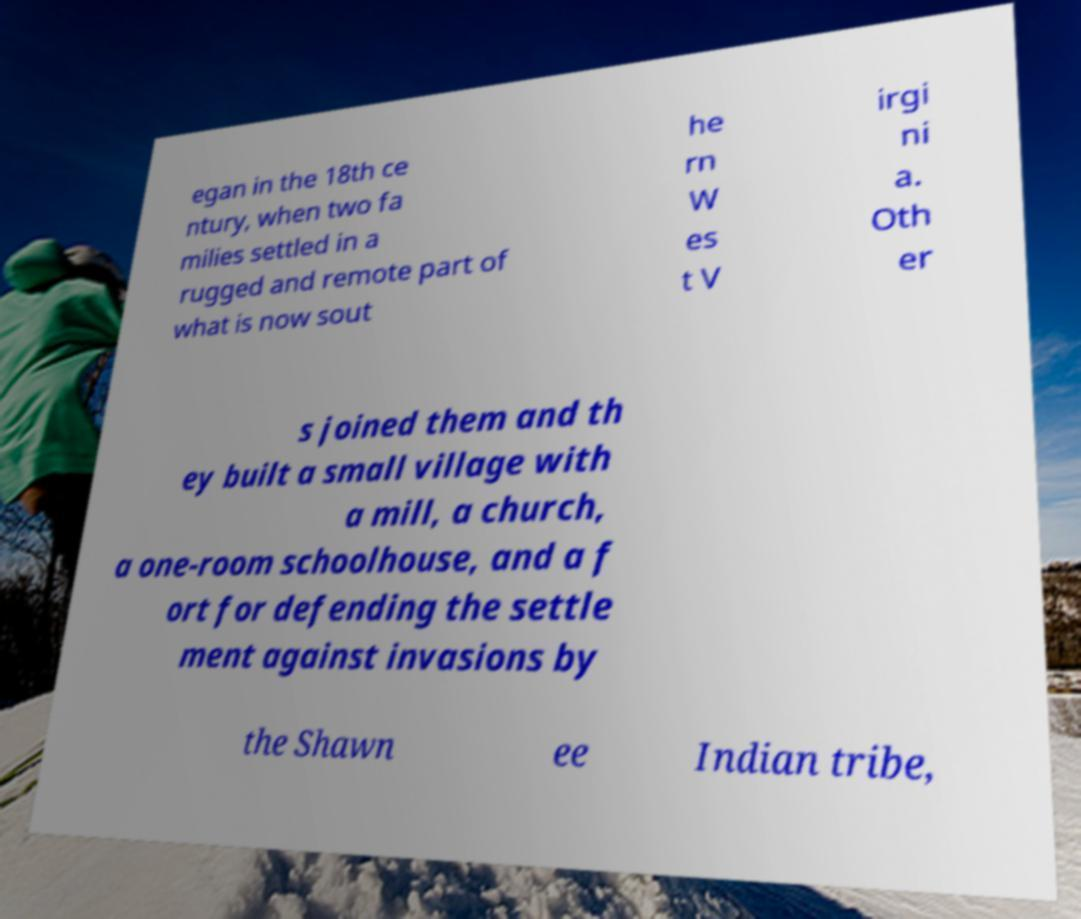Can you accurately transcribe the text from the provided image for me? egan in the 18th ce ntury, when two fa milies settled in a rugged and remote part of what is now sout he rn W es t V irgi ni a. Oth er s joined them and th ey built a small village with a mill, a church, a one-room schoolhouse, and a f ort for defending the settle ment against invasions by the Shawn ee Indian tribe, 